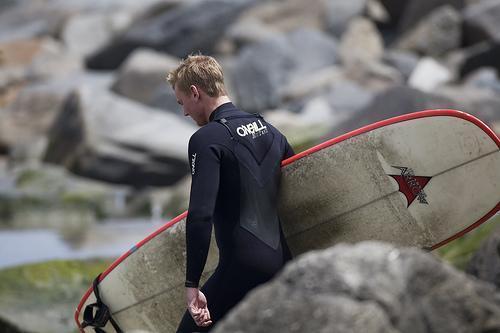How many people are in the photo?
Give a very brief answer. 1. 